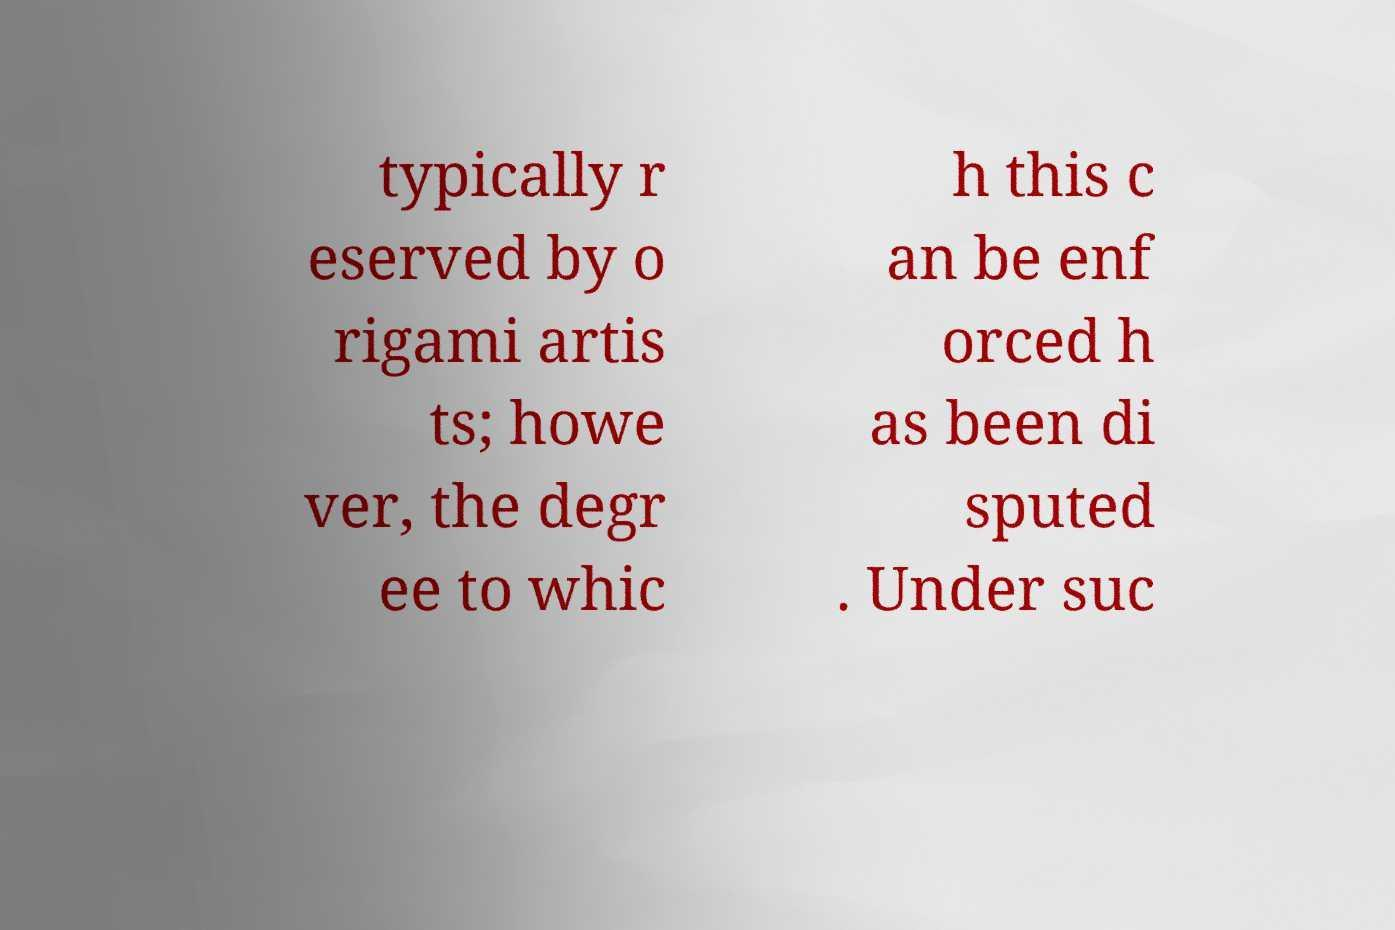Can you read and provide the text displayed in the image?This photo seems to have some interesting text. Can you extract and type it out for me? typically r eserved by o rigami artis ts; howe ver, the degr ee to whic h this c an be enf orced h as been di sputed . Under suc 